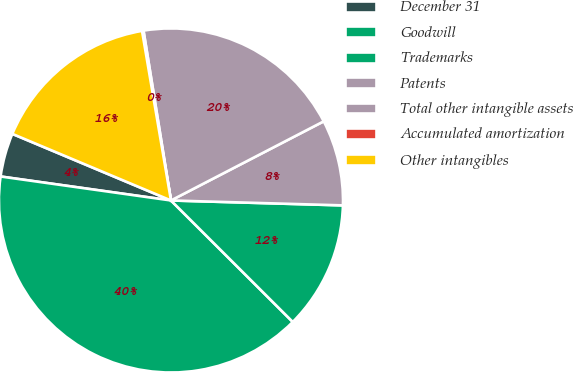Convert chart to OTSL. <chart><loc_0><loc_0><loc_500><loc_500><pie_chart><fcel>December 31<fcel>Goodwill<fcel>Trademarks<fcel>Patents<fcel>Total other intangible assets<fcel>Accumulated amortization<fcel>Other intangibles<nl><fcel>4.1%<fcel>39.74%<fcel>12.02%<fcel>8.06%<fcel>19.94%<fcel>0.14%<fcel>15.98%<nl></chart> 